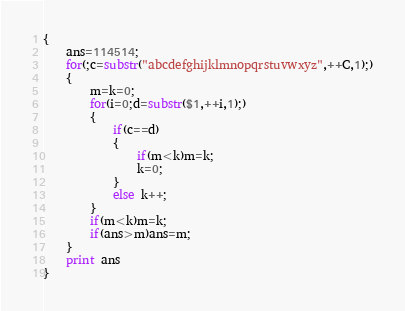<code> <loc_0><loc_0><loc_500><loc_500><_Awk_>{
	ans=114514;
	for(;c=substr("abcdefghijklmnopqrstuvwxyz",++C,1);)
	{
		m=k=0;
		for(i=0;d=substr($1,++i,1);)
		{
			if(c==d)
			{
				if(m<k)m=k;
				k=0;
			}
			else k++;
		}
		if(m<k)m=k;
		if(ans>m)ans=m;
	}
	print ans
}
</code> 